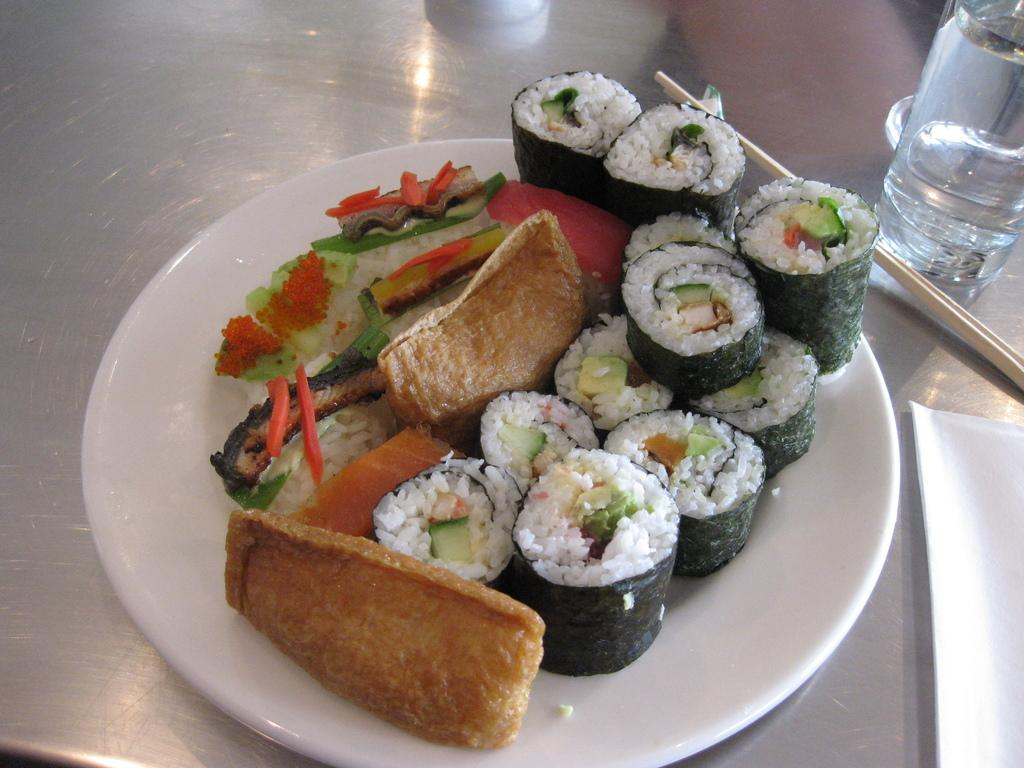What is on the plate that is visible in the image? There is food on the plate in the image. What else can be seen in the image besides the plate? There is a glass of drink, a chopstick, and a tissue paper visible in the image. What might be used for eating the food on the plate? The chopstick in the image might be used for eating the food. What is the purpose of the tissue paper in the image? The tissue paper might be used for wiping or cleaning purposes. What type of quill can be seen in the image? There is no quill present in the image. Can you describe the cemetery in the image? There is no cemetery present in the image. 